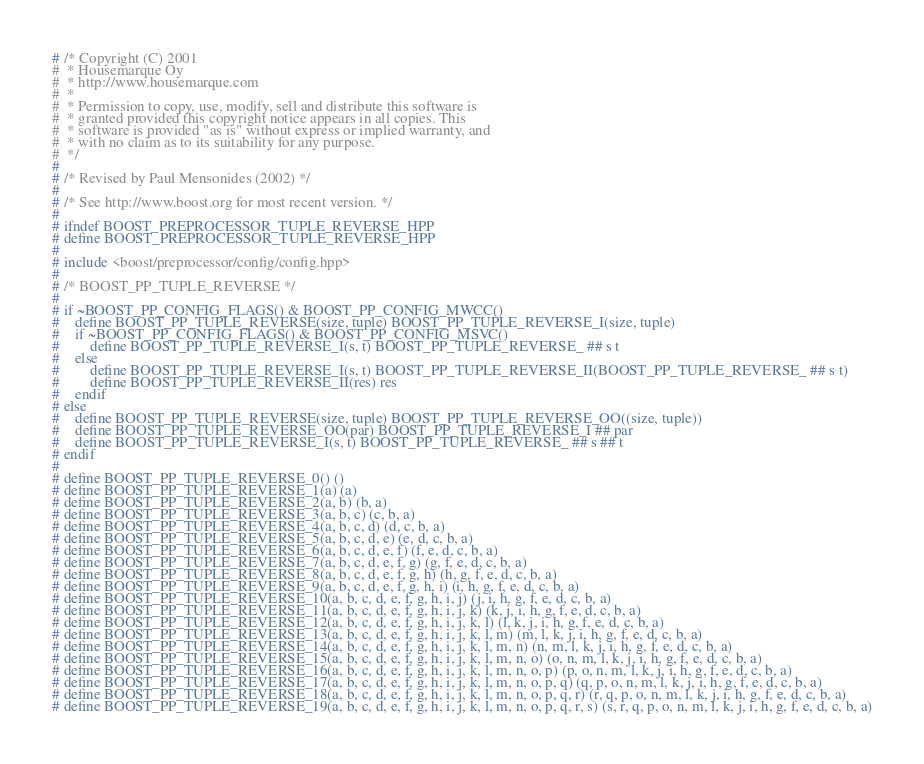<code> <loc_0><loc_0><loc_500><loc_500><_C++_># /* Copyright (C) 2001
#  * Housemarque Oy
#  * http://www.housemarque.com
#  *
#  * Permission to copy, use, modify, sell and distribute this software is
#  * granted provided this copyright notice appears in all copies. This
#  * software is provided "as is" without express or implied warranty, and
#  * with no claim as to its suitability for any purpose.
#  */
#
# /* Revised by Paul Mensonides (2002) */
#
# /* See http://www.boost.org for most recent version. */
#
# ifndef BOOST_PREPROCESSOR_TUPLE_REVERSE_HPP
# define BOOST_PREPROCESSOR_TUPLE_REVERSE_HPP
#
# include <boost/preprocessor/config/config.hpp>
#
# /* BOOST_PP_TUPLE_REVERSE */
#
# if ~BOOST_PP_CONFIG_FLAGS() & BOOST_PP_CONFIG_MWCC()
#    define BOOST_PP_TUPLE_REVERSE(size, tuple) BOOST_PP_TUPLE_REVERSE_I(size, tuple)
#    if ~BOOST_PP_CONFIG_FLAGS() & BOOST_PP_CONFIG_MSVC()
#        define BOOST_PP_TUPLE_REVERSE_I(s, t) BOOST_PP_TUPLE_REVERSE_ ## s t
#    else
#        define BOOST_PP_TUPLE_REVERSE_I(s, t) BOOST_PP_TUPLE_REVERSE_II(BOOST_PP_TUPLE_REVERSE_ ## s t)
#        define BOOST_PP_TUPLE_REVERSE_II(res) res
#    endif
# else
#    define BOOST_PP_TUPLE_REVERSE(size, tuple) BOOST_PP_TUPLE_REVERSE_OO((size, tuple))
#    define BOOST_PP_TUPLE_REVERSE_OO(par) BOOST_PP_TUPLE_REVERSE_I ## par
#    define BOOST_PP_TUPLE_REVERSE_I(s, t) BOOST_PP_TUPLE_REVERSE_ ## s ## t
# endif
#
# define BOOST_PP_TUPLE_REVERSE_0() ()
# define BOOST_PP_TUPLE_REVERSE_1(a) (a)
# define BOOST_PP_TUPLE_REVERSE_2(a, b) (b, a)
# define BOOST_PP_TUPLE_REVERSE_3(a, b, c) (c, b, a)
# define BOOST_PP_TUPLE_REVERSE_4(a, b, c, d) (d, c, b, a)
# define BOOST_PP_TUPLE_REVERSE_5(a, b, c, d, e) (e, d, c, b, a)
# define BOOST_PP_TUPLE_REVERSE_6(a, b, c, d, e, f) (f, e, d, c, b, a)
# define BOOST_PP_TUPLE_REVERSE_7(a, b, c, d, e, f, g) (g, f, e, d, c, b, a)
# define BOOST_PP_TUPLE_REVERSE_8(a, b, c, d, e, f, g, h) (h, g, f, e, d, c, b, a)
# define BOOST_PP_TUPLE_REVERSE_9(a, b, c, d, e, f, g, h, i) (i, h, g, f, e, d, c, b, a)
# define BOOST_PP_TUPLE_REVERSE_10(a, b, c, d, e, f, g, h, i, j) (j, i, h, g, f, e, d, c, b, a)
# define BOOST_PP_TUPLE_REVERSE_11(a, b, c, d, e, f, g, h, i, j, k) (k, j, i, h, g, f, e, d, c, b, a)
# define BOOST_PP_TUPLE_REVERSE_12(a, b, c, d, e, f, g, h, i, j, k, l) (l, k, j, i, h, g, f, e, d, c, b, a)
# define BOOST_PP_TUPLE_REVERSE_13(a, b, c, d, e, f, g, h, i, j, k, l, m) (m, l, k, j, i, h, g, f, e, d, c, b, a)
# define BOOST_PP_TUPLE_REVERSE_14(a, b, c, d, e, f, g, h, i, j, k, l, m, n) (n, m, l, k, j, i, h, g, f, e, d, c, b, a)
# define BOOST_PP_TUPLE_REVERSE_15(a, b, c, d, e, f, g, h, i, j, k, l, m, n, o) (o, n, m, l, k, j, i, h, g, f, e, d, c, b, a)
# define BOOST_PP_TUPLE_REVERSE_16(a, b, c, d, e, f, g, h, i, j, k, l, m, n, o, p) (p, o, n, m, l, k, j, i, h, g, f, e, d, c, b, a)
# define BOOST_PP_TUPLE_REVERSE_17(a, b, c, d, e, f, g, h, i, j, k, l, m, n, o, p, q) (q, p, o, n, m, l, k, j, i, h, g, f, e, d, c, b, a)
# define BOOST_PP_TUPLE_REVERSE_18(a, b, c, d, e, f, g, h, i, j, k, l, m, n, o, p, q, r) (r, q, p, o, n, m, l, k, j, i, h, g, f, e, d, c, b, a)
# define BOOST_PP_TUPLE_REVERSE_19(a, b, c, d, e, f, g, h, i, j, k, l, m, n, o, p, q, r, s) (s, r, q, p, o, n, m, l, k, j, i, h, g, f, e, d, c, b, a)</code> 